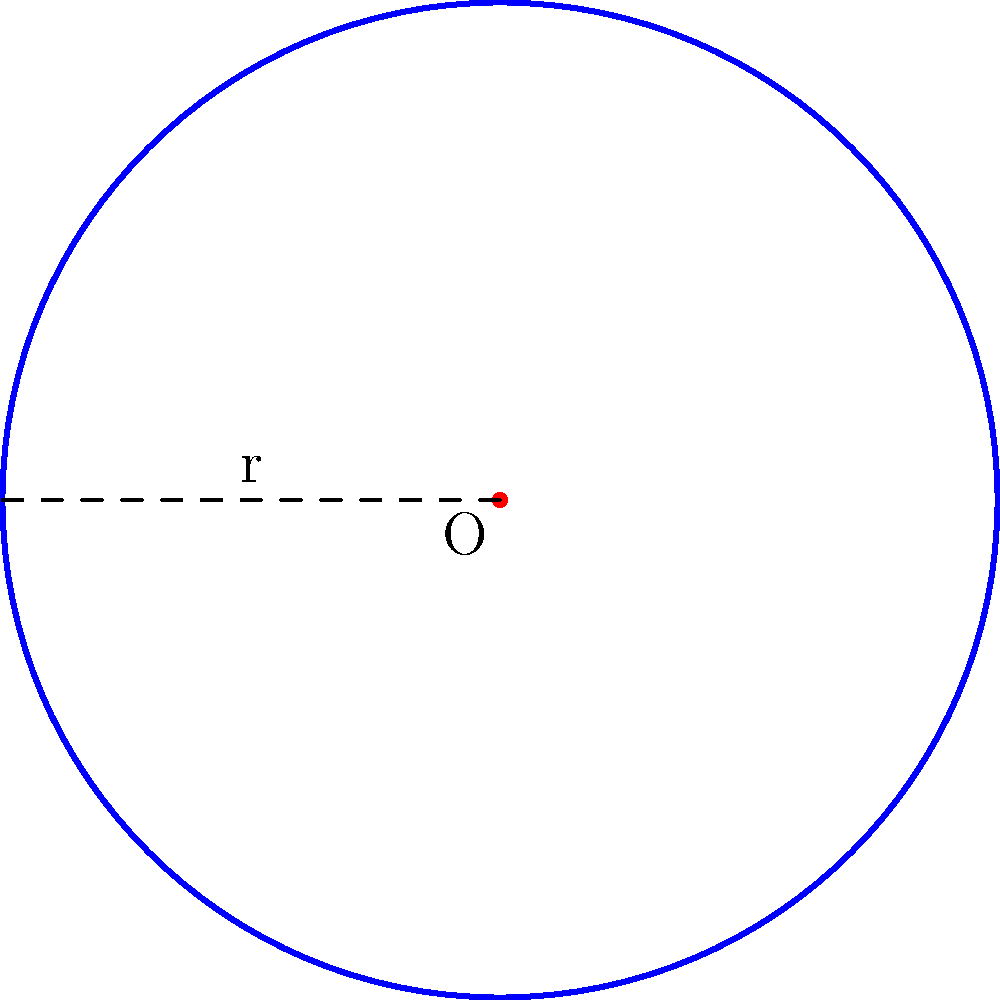A circular meditation labyrinth has a radius of 15 meters. What is the circumference of the labyrinth, rounded to the nearest meter? To find the circumference of a circular meditation labyrinth, we need to use the formula for the circumference of a circle:

$$C = 2\pi r$$

Where:
$C$ = circumference
$\pi$ = pi (approximately 3.14159)
$r$ = radius

Given:
Radius ($r$) = 15 meters

Step 1: Substitute the values into the formula
$$C = 2\pi(15)$$

Step 2: Calculate
$$C = 2(3.14159)(15)$$
$$C = 94.24770 \text{ meters}$$

Step 3: Round to the nearest meter
$$C \approx 94 \text{ meters}$$

Therefore, the circumference of the circular meditation labyrinth is approximately 94 meters.
Answer: 94 meters 